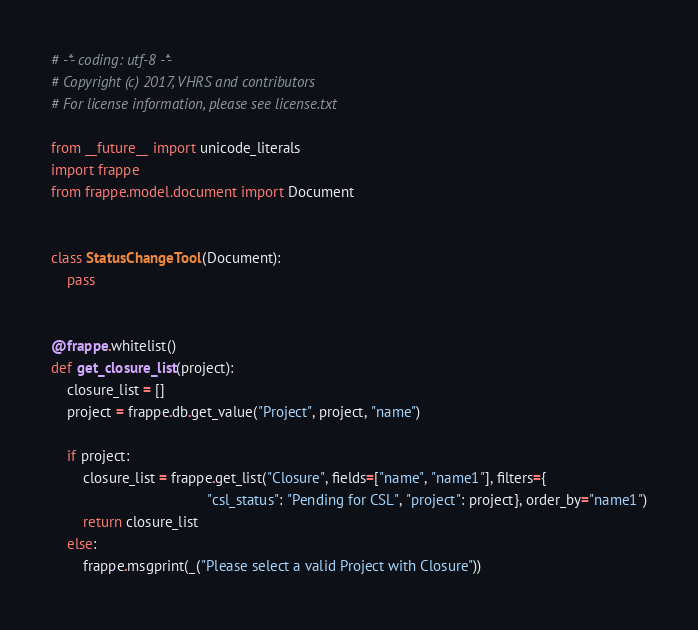Convert code to text. <code><loc_0><loc_0><loc_500><loc_500><_Python_># -*- coding: utf-8 -*-
# Copyright (c) 2017, VHRS and contributors
# For license information, please see license.txt

from __future__ import unicode_literals
import frappe
from frappe.model.document import Document


class StatusChangeTool(Document):
    pass


@frappe.whitelist()
def get_closure_list(project):
    closure_list = []
    project = frappe.db.get_value("Project", project, "name")

    if project:
        closure_list = frappe.get_list("Closure", fields=["name", "name1"], filters={
                                       "csl_status": "Pending for CSL", "project": project}, order_by="name1")
        return closure_list
    else:
        frappe.msgprint(_("Please select a valid Project with Closure"))
</code> 